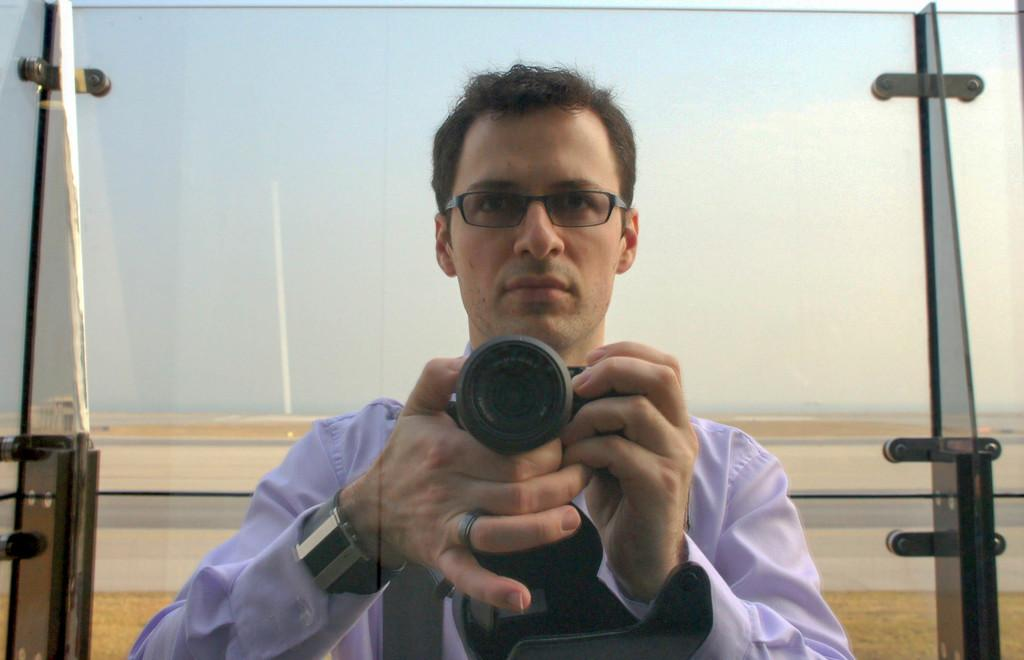What is the main subject of the image? There is a man in the image. What is the man holding in the image? The man is holding a camera. What type of cannon is the man using to take pictures in the image? There is no cannon present in the image; the man is holding a camera. What type of skin condition does the man have in the image? There is no information about the man's skin condition in the image. 